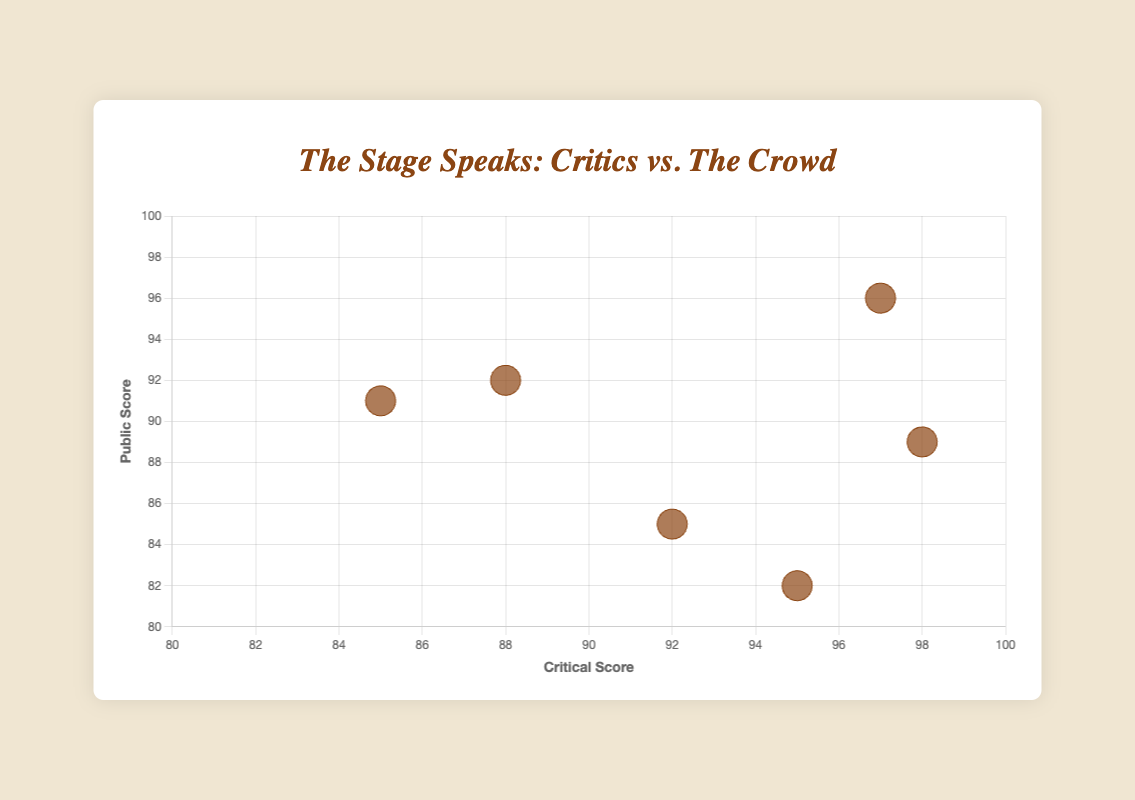What's the title of the chart? The title is displayed at the top of the chart and reads, "The Stage Speaks: Critics vs. The Crowd".
Answer: The Stage Speaks: Critics vs. The Crowd What are the ranges of the x and y axes? The x-axis (Critical Score) ranges from 80 to 100, while the y-axis (Public Score) ranges from 80 to 100. These ranges are marked on the axes of the chart.
Answer: 80 to 100 Whose public score is higher than their critical score? To find this, compare the 'public_score' with 'critical_score' for each talent. Timothée Chalamet (92 vs. 88) and Ben Platt (91 vs. 85) have higher public scores than critical scores.
Answer: Timothée Chalamet, Ben Platt Who received the highest critical score? Look for the highest point on the x-axis (Critical Score). Phoebe Waller-Bridge received a critical score of 98, making it the highest.
Answer: Phoebe Waller-Bridge What is the difference between Lin-Manuel Miranda's critical and public scores? Lin-Manuel Miranda's critical score is 97 and his public score is 96. The difference is calculated as 97 - 96 = 1.
Answer: 1 Which talent has the widest gap between their critical and public scores? Calculate the absolute difference for each talent. Emma Thompson (95 - 82 = 13) has the widest gap between critical and public scores.
Answer: Emma Thompson Who has the emoji 🌟 in the dataset? The dataset includes an emoji for Timothée Chalamet, which is 🌟. This can be observed in the data labels used in the scatter plot.
Answer: Timothée Chalamet Compare Phoebe Waller-Bridge and Cynthia Erivo’s public scores. Who has the higher score? Phoebe Waller-Bridge has a public score of 89, and Cynthia Erivo has a score of 85. Hence, Phoebe Waller-Bridge has the higher public score.
Answer: Phoebe Waller-Bridge How many talents have both critical and public scores above 90? Check each talent’s scores to see if both are above 90. Only Lin-Manuel Miranda fits this criterion.
Answer: 1 